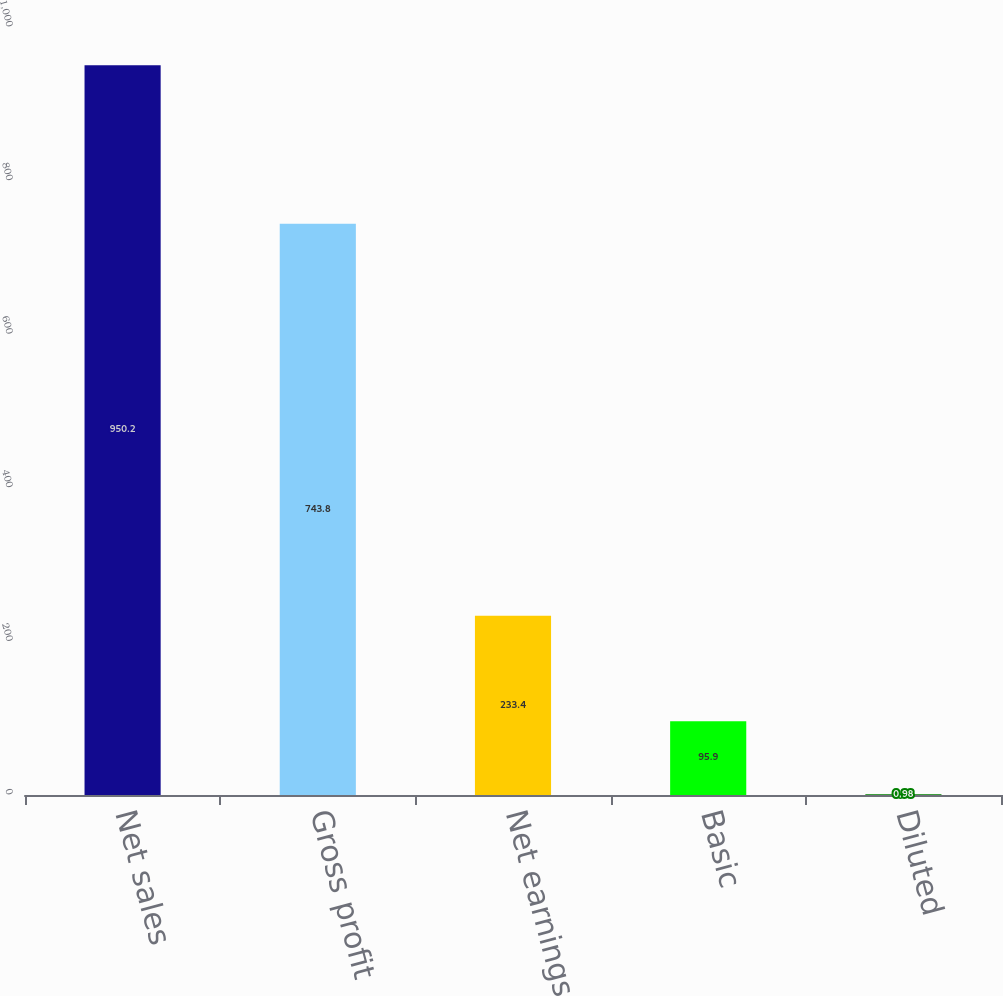Convert chart to OTSL. <chart><loc_0><loc_0><loc_500><loc_500><bar_chart><fcel>Net sales<fcel>Gross profit<fcel>Net earnings<fcel>Basic<fcel>Diluted<nl><fcel>950.2<fcel>743.8<fcel>233.4<fcel>95.9<fcel>0.98<nl></chart> 